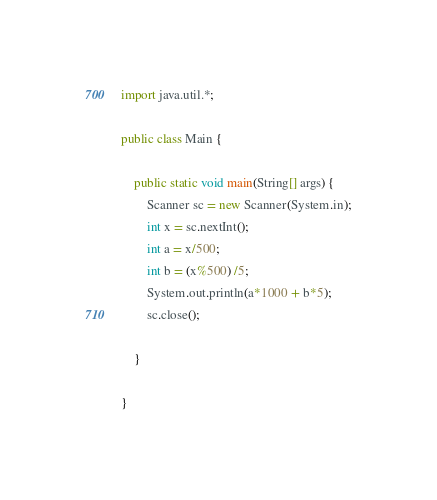Convert code to text. <code><loc_0><loc_0><loc_500><loc_500><_Java_>import java.util.*;

public class Main {

    public static void main(String[] args) {
        Scanner sc = new Scanner(System.in);
        int x = sc.nextInt();
        int a = x/500;
        int b = (x%500) /5;
        System.out.println(a*1000 + b*5);
        sc.close();

    }

}
</code> 